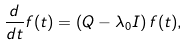<formula> <loc_0><loc_0><loc_500><loc_500>\frac { d } { d t } { f } ( t ) = \left ( { Q } - \lambda _ { 0 } { I } \right ) { f } ( t ) ,</formula> 